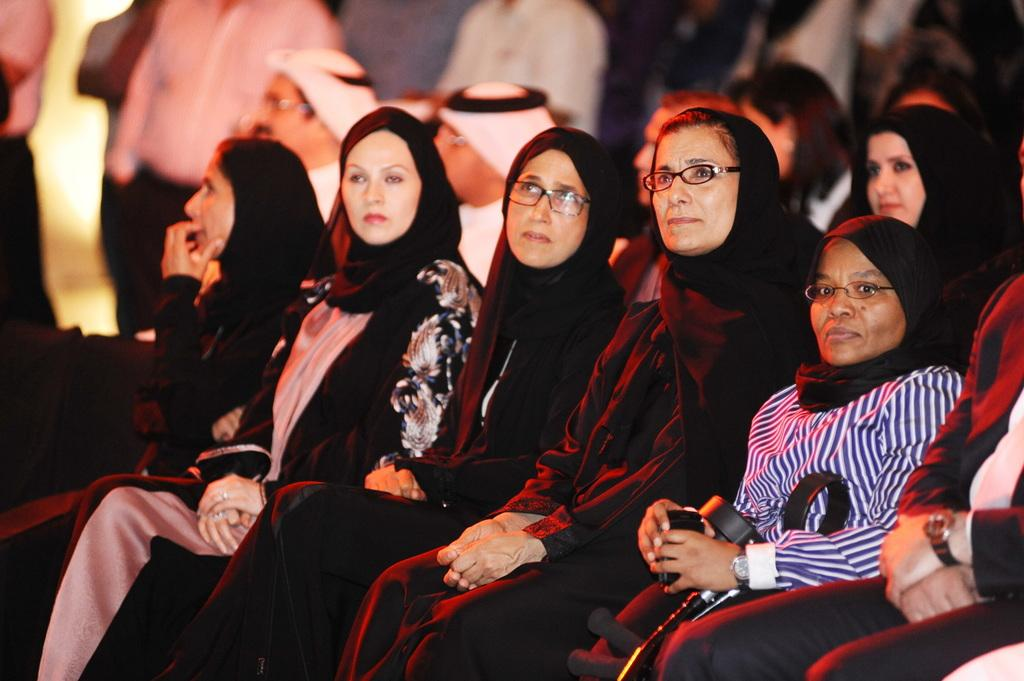What are the people in the image doing? The people in the image are sitting. Can you describe the clothing of the people in the image? The people are wearing different color dresses. What can be observed about the background of the image? The background of the image is blurred. What type of powder is being used by the people in the image? There is no powder present in the image; the people are simply sitting and wearing different color dresses. 